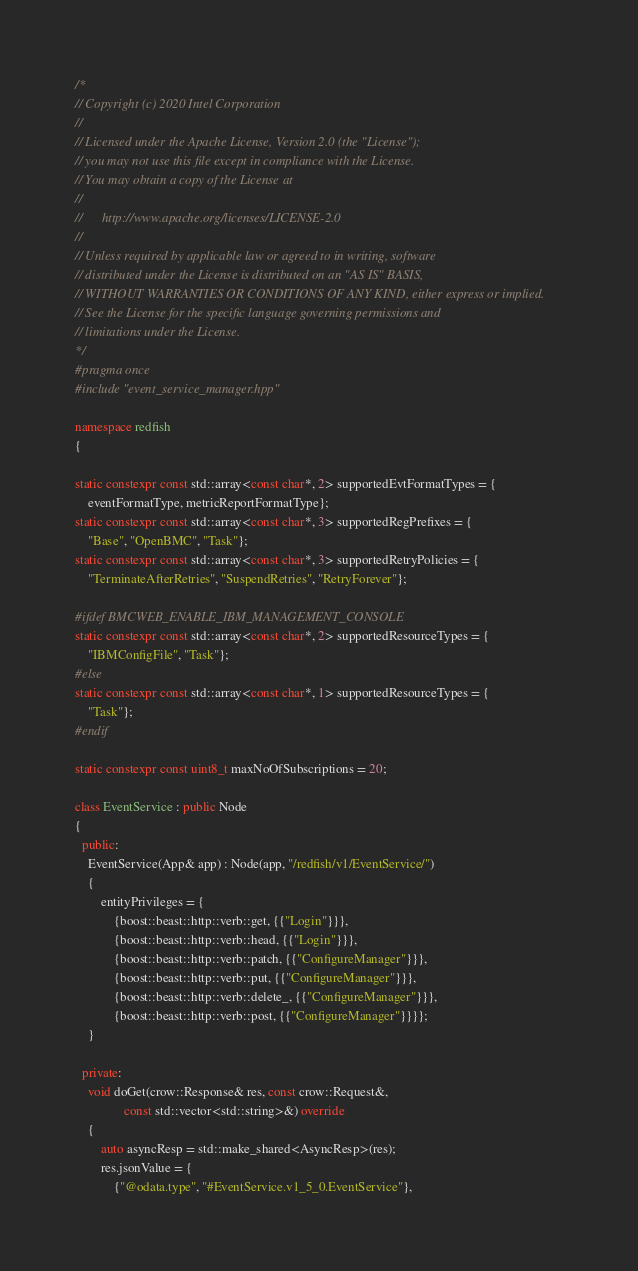Convert code to text. <code><loc_0><loc_0><loc_500><loc_500><_C++_>/*
// Copyright (c) 2020 Intel Corporation
//
// Licensed under the Apache License, Version 2.0 (the "License");
// you may not use this file except in compliance with the License.
// You may obtain a copy of the License at
//
//      http://www.apache.org/licenses/LICENSE-2.0
//
// Unless required by applicable law or agreed to in writing, software
// distributed under the License is distributed on an "AS IS" BASIS,
// WITHOUT WARRANTIES OR CONDITIONS OF ANY KIND, either express or implied.
// See the License for the specific language governing permissions and
// limitations under the License.
*/
#pragma once
#include "event_service_manager.hpp"

namespace redfish
{

static constexpr const std::array<const char*, 2> supportedEvtFormatTypes = {
    eventFormatType, metricReportFormatType};
static constexpr const std::array<const char*, 3> supportedRegPrefixes = {
    "Base", "OpenBMC", "Task"};
static constexpr const std::array<const char*, 3> supportedRetryPolicies = {
    "TerminateAfterRetries", "SuspendRetries", "RetryForever"};

#ifdef BMCWEB_ENABLE_IBM_MANAGEMENT_CONSOLE
static constexpr const std::array<const char*, 2> supportedResourceTypes = {
    "IBMConfigFile", "Task"};
#else
static constexpr const std::array<const char*, 1> supportedResourceTypes = {
    "Task"};
#endif

static constexpr const uint8_t maxNoOfSubscriptions = 20;

class EventService : public Node
{
  public:
    EventService(App& app) : Node(app, "/redfish/v1/EventService/")
    {
        entityPrivileges = {
            {boost::beast::http::verb::get, {{"Login"}}},
            {boost::beast::http::verb::head, {{"Login"}}},
            {boost::beast::http::verb::patch, {{"ConfigureManager"}}},
            {boost::beast::http::verb::put, {{"ConfigureManager"}}},
            {boost::beast::http::verb::delete_, {{"ConfigureManager"}}},
            {boost::beast::http::verb::post, {{"ConfigureManager"}}}};
    }

  private:
    void doGet(crow::Response& res, const crow::Request&,
               const std::vector<std::string>&) override
    {
        auto asyncResp = std::make_shared<AsyncResp>(res);
        res.jsonValue = {
            {"@odata.type", "#EventService.v1_5_0.EventService"},</code> 